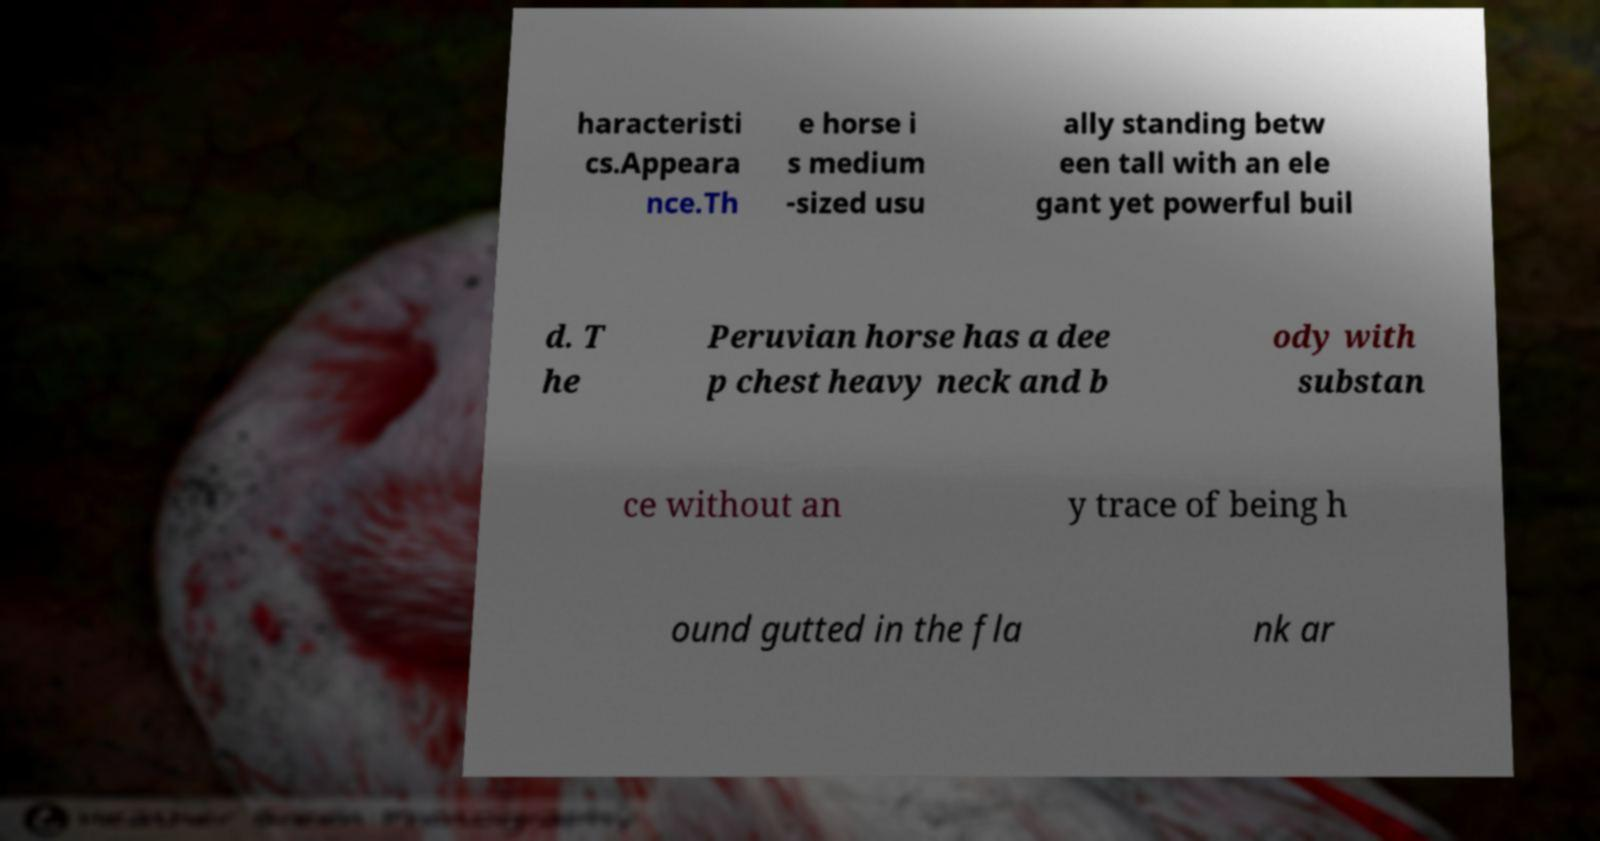Could you assist in decoding the text presented in this image and type it out clearly? haracteristi cs.Appeara nce.Th e horse i s medium -sized usu ally standing betw een tall with an ele gant yet powerful buil d. T he Peruvian horse has a dee p chest heavy neck and b ody with substan ce without an y trace of being h ound gutted in the fla nk ar 